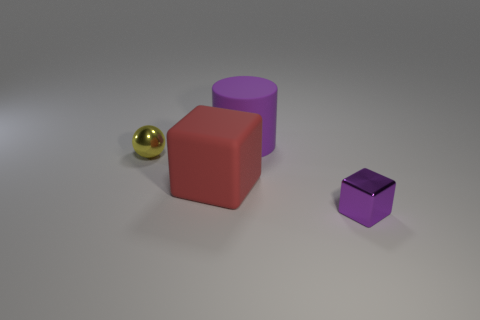How many other rubber cubes are the same color as the matte cube?
Your answer should be compact. 0. There is a small shiny object that is in front of the big matte object in front of the purple rubber thing; what shape is it?
Ensure brevity in your answer.  Cube. How many cubes are made of the same material as the small yellow ball?
Give a very brief answer. 1. There is a purple thing behind the yellow metallic object; what material is it?
Ensure brevity in your answer.  Rubber. What shape is the small object that is behind the tiny purple block that is in front of the rubber object that is in front of the tiny yellow shiny ball?
Make the answer very short. Sphere. There is a small thing that is to the left of the tiny purple thing; is its color the same as the metallic thing on the right side of the yellow sphere?
Keep it short and to the point. No. Are there fewer small yellow things that are in front of the yellow metallic sphere than purple matte objects behind the purple rubber cylinder?
Your response must be concise. No. Is there any other thing that has the same shape as the small purple thing?
Provide a succinct answer. Yes. There is another thing that is the same shape as the large red matte object; what color is it?
Give a very brief answer. Purple. There is a red matte thing; is it the same shape as the shiny thing that is right of the yellow metal sphere?
Provide a short and direct response. Yes. 